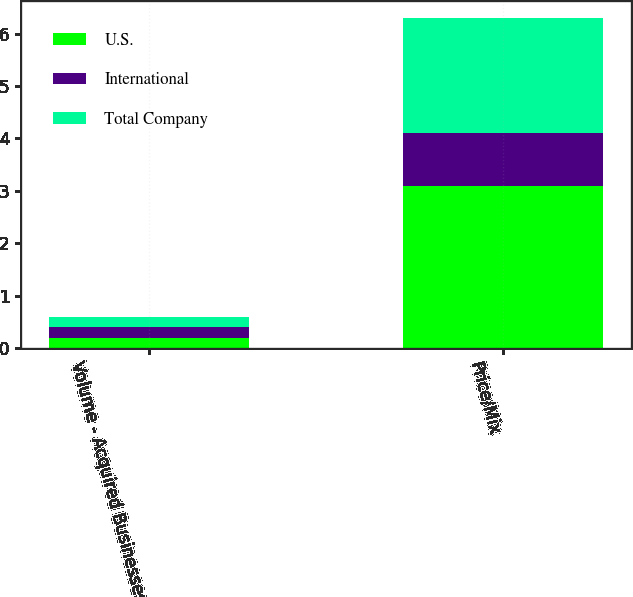Convert chart. <chart><loc_0><loc_0><loc_500><loc_500><stacked_bar_chart><ecel><fcel>Volume - Acquired Businesses<fcel>Price/Mix<nl><fcel>U.S.<fcel>0.2<fcel>3.1<nl><fcel>International<fcel>0.2<fcel>1<nl><fcel>Total Company<fcel>0.2<fcel>2.2<nl></chart> 